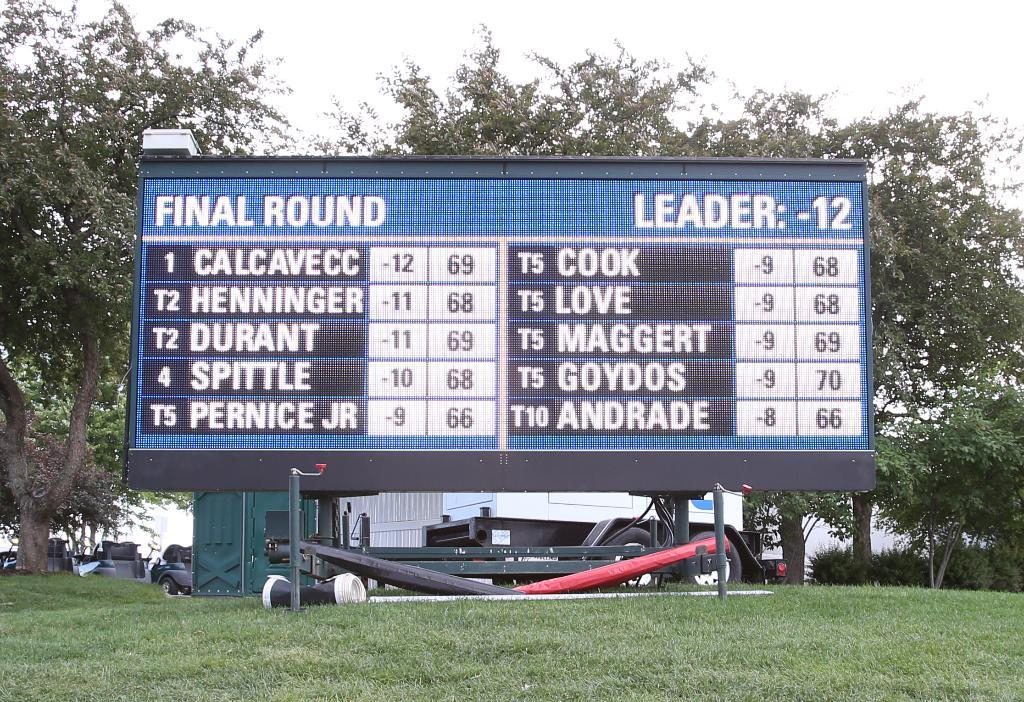<image>
Render a clear and concise summary of the photo. a sign that has the word final round on it 